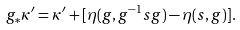Convert formula to latex. <formula><loc_0><loc_0><loc_500><loc_500>g _ { \ast } \kappa ^ { \prime } = \kappa ^ { \prime } + [ \eta ( g , g ^ { - 1 } s g ) - \eta ( s , g ) ] .</formula> 